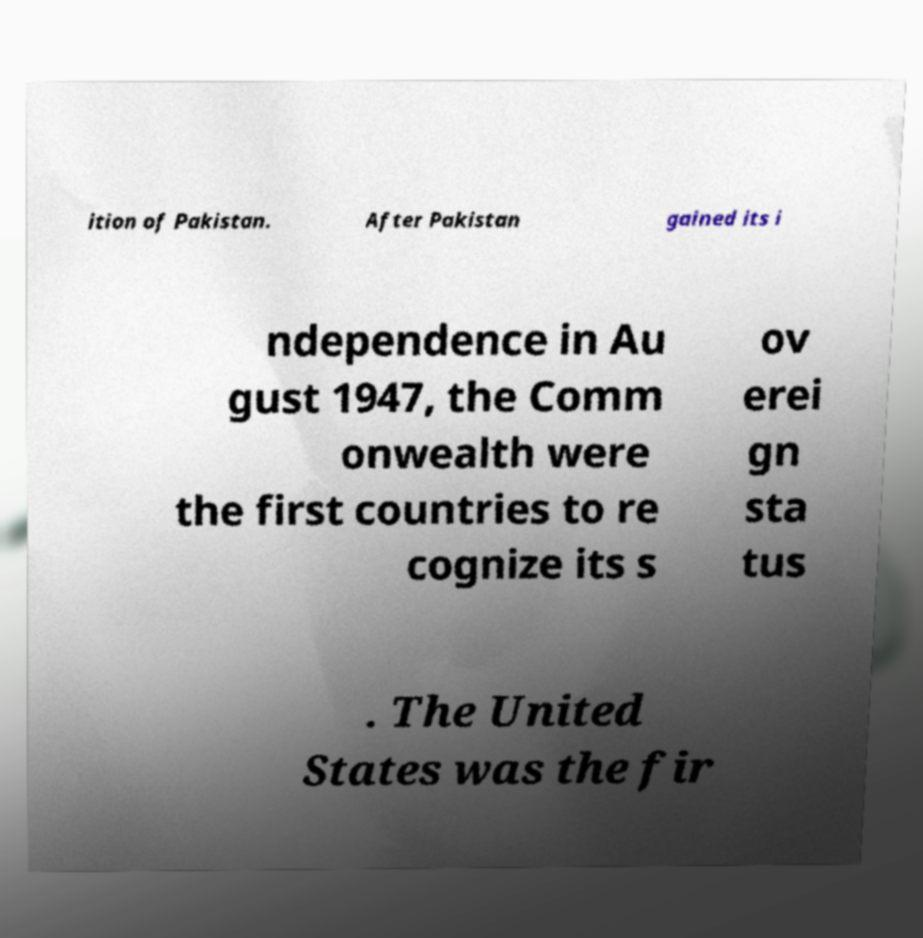For documentation purposes, I need the text within this image transcribed. Could you provide that? ition of Pakistan. After Pakistan gained its i ndependence in Au gust 1947, the Comm onwealth were the first countries to re cognize its s ov erei gn sta tus . The United States was the fir 